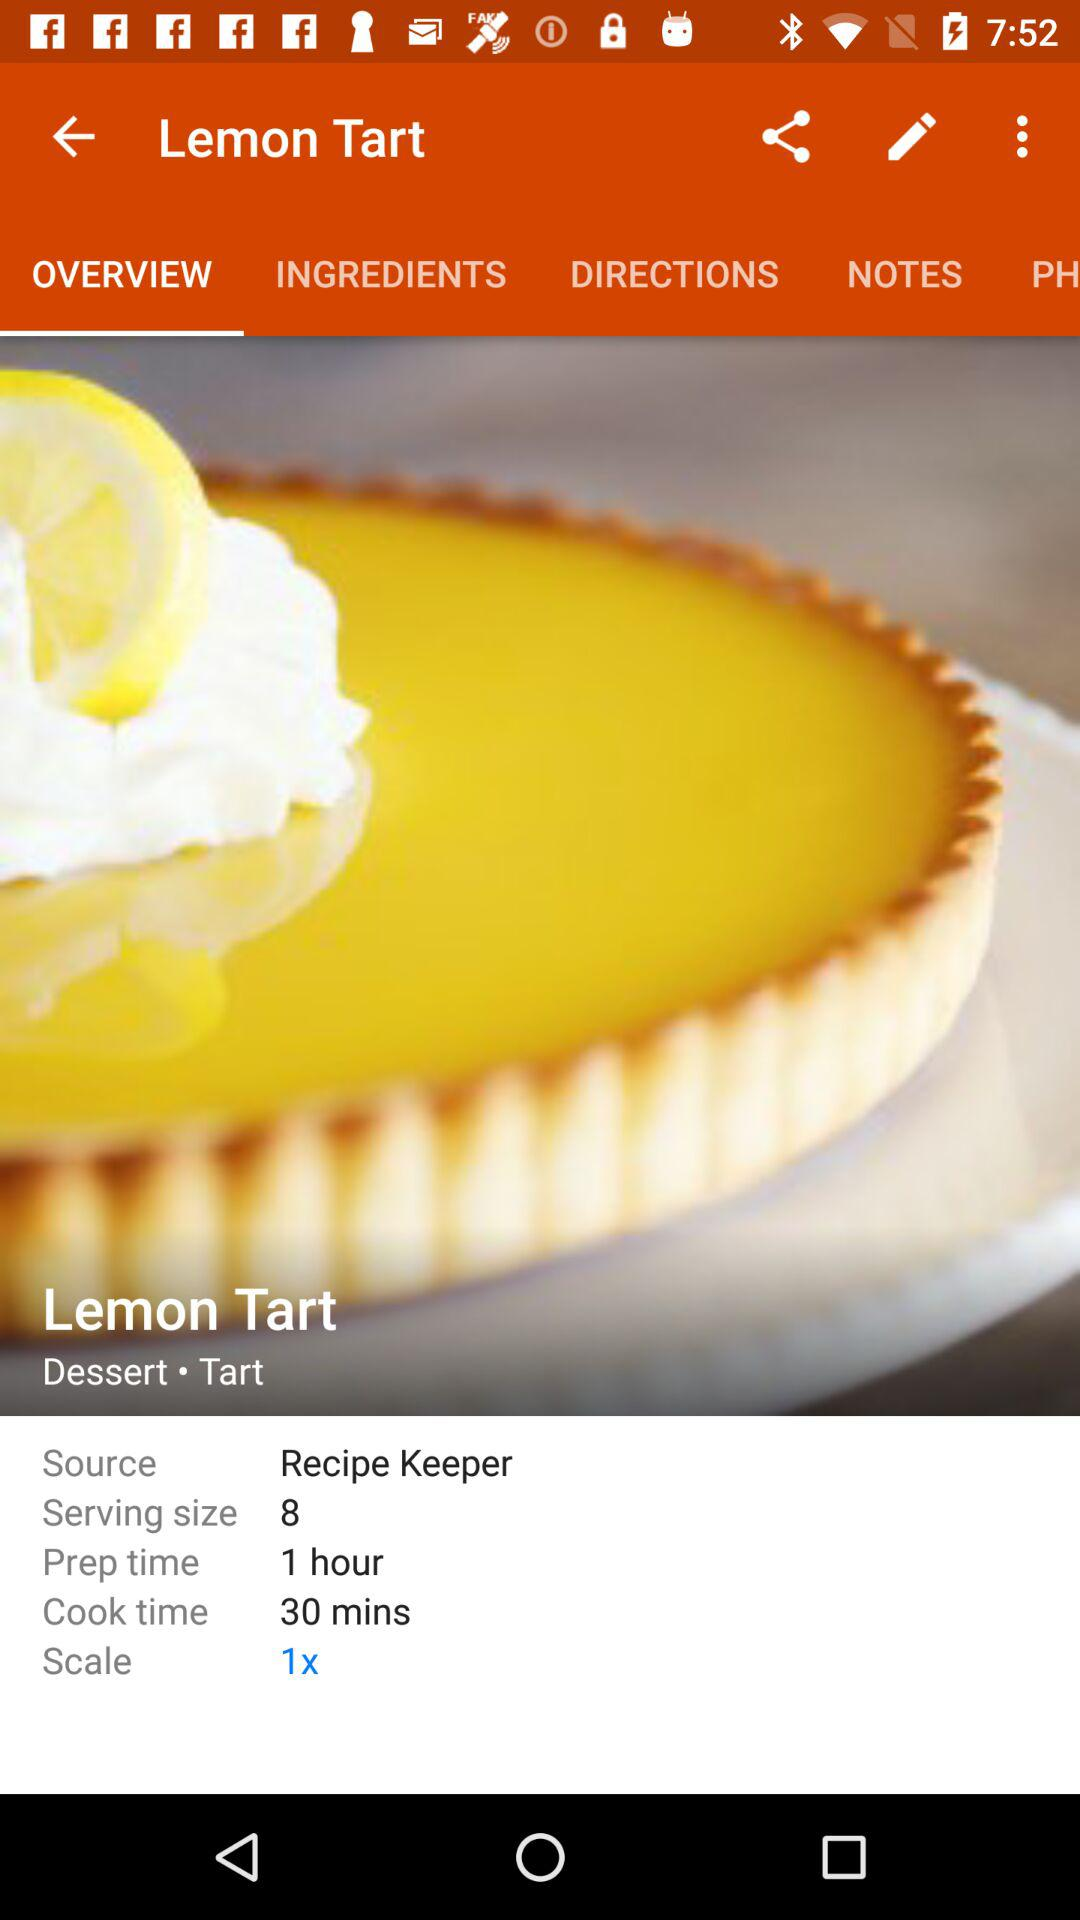How many more people can this recipe feed if the serving size is doubled?
Answer the question using a single word or phrase. 16 